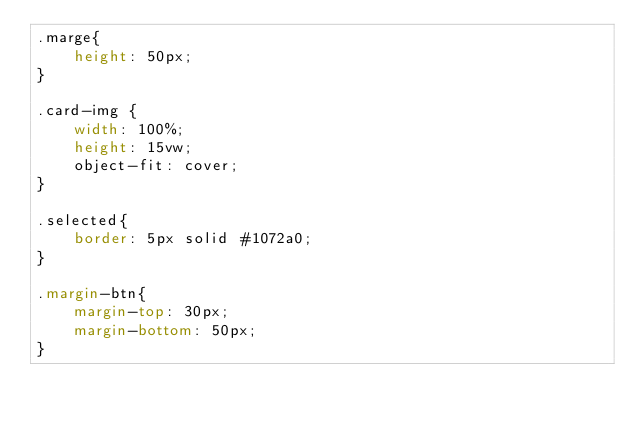Convert code to text. <code><loc_0><loc_0><loc_500><loc_500><_CSS_>.marge{
    height: 50px;
}

.card-img {
    width: 100%;
    height: 15vw;
    object-fit: cover;
}

.selected{
    border: 5px solid #1072a0;
}

.margin-btn{
    margin-top: 30px;
    margin-bottom: 50px;
}</code> 